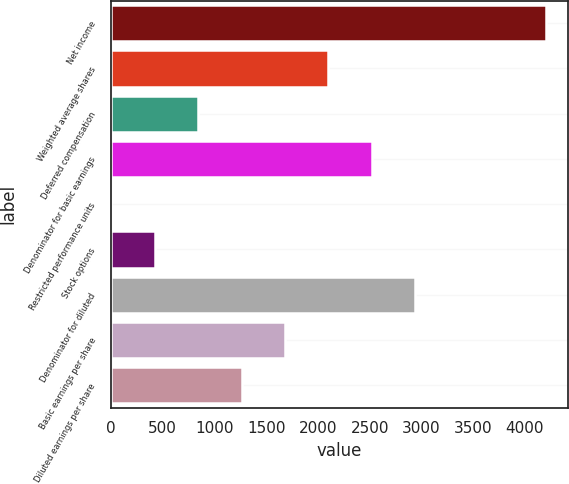Convert chart to OTSL. <chart><loc_0><loc_0><loc_500><loc_500><bar_chart><fcel>Net income<fcel>Weighted average shares<fcel>Deferred compensation<fcel>Denominator for basic earnings<fcel>Restricted performance units<fcel>Stock options<fcel>Denominator for diluted<fcel>Basic earnings per share<fcel>Diluted earnings per share<nl><fcel>4202<fcel>2101.5<fcel>841.2<fcel>2521.6<fcel>1<fcel>421.1<fcel>2941.7<fcel>1681.4<fcel>1261.3<nl></chart> 